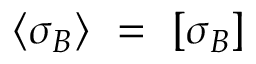Convert formula to latex. <formula><loc_0><loc_0><loc_500><loc_500>\langle { \sigma _ { B } } \rangle = [ \sigma _ { B } ]</formula> 